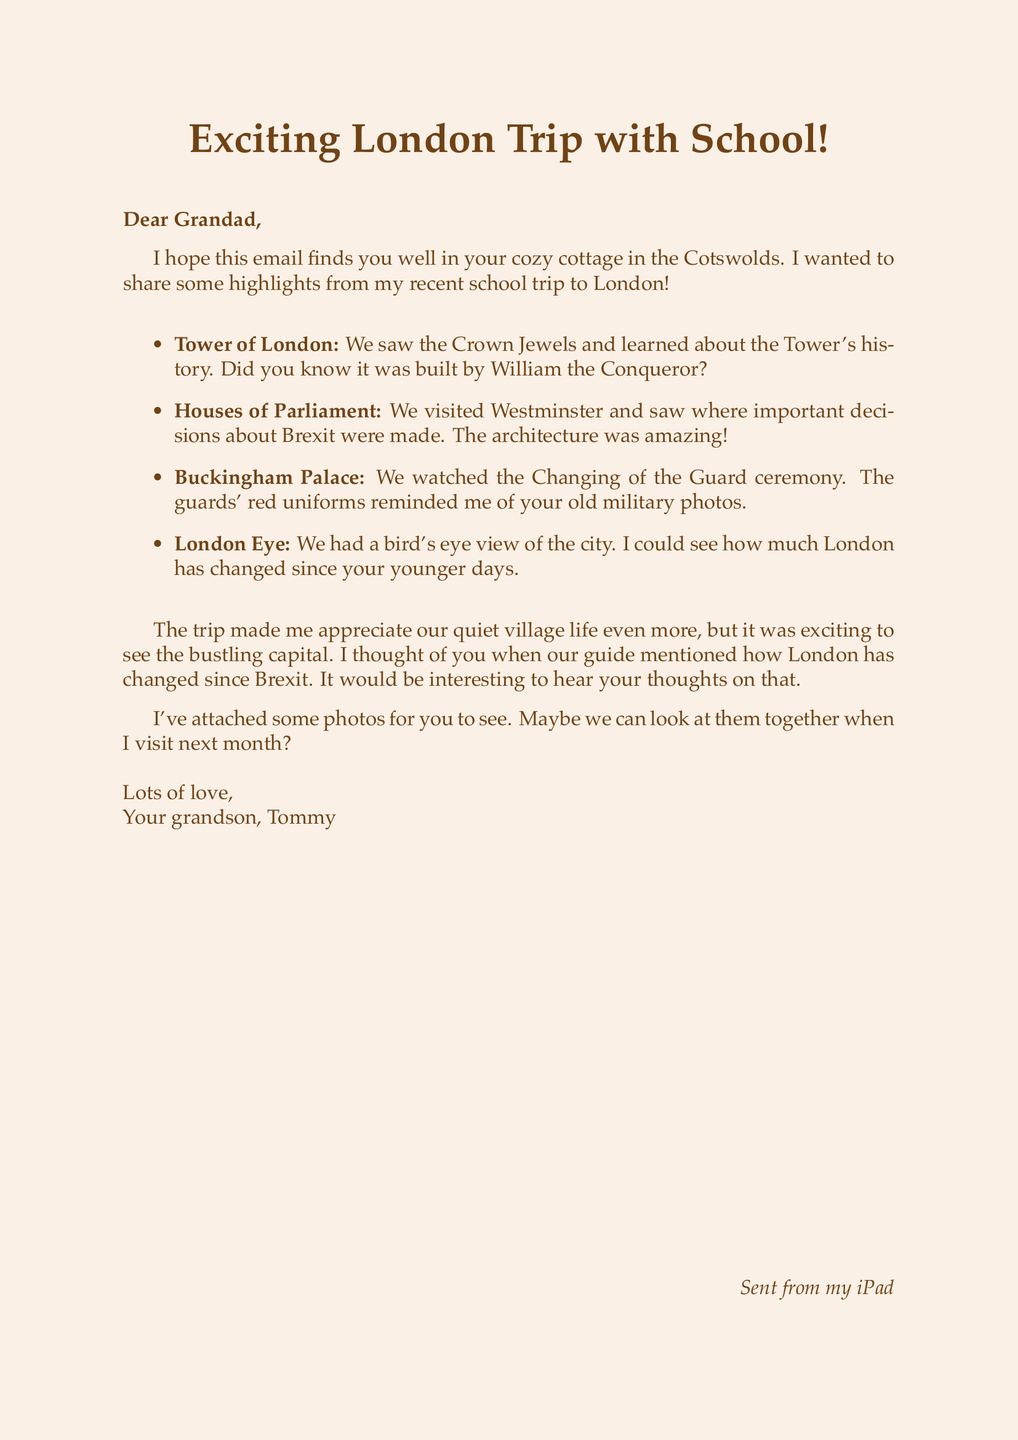what city did Tommy visit on his school trip? The email mentions a school trip to London, which is the city.
Answer: London how many key points does Tommy share about his trip? The email lists four key points about Tommy's trip, indicating the number of key highlights shared.
Answer: 4 which landmark did they see the Crown Jewels? Tommy mentions visiting the Tower of London where they saw the Crown Jewels.
Answer: Tower of London what ceremony did Tommy watch at Buckingham Palace? He describes watching the Changing of the Guard ceremony at Buckingham Palace.
Answer: Changing of the Guard who sent the email? The email is sent by Tommy to his grandad, identifying the sender.
Answer: Tommy what did Tommy think about their village life after the trip? He reflects that the trip made him appreciate their quiet village life even more.
Answer: Appreciate what did the guide mention that made Tommy think of his grandad? The guide's mention of how London has changed since Brexit prompted Tommy to think of his grandad.
Answer: Brexit how does Tommy close the email? The email is closed with "Lots of love," followed by his name.
Answer: Lots of love 